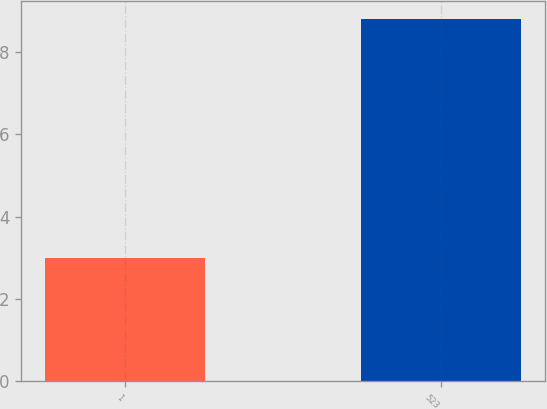Convert chart to OTSL. <chart><loc_0><loc_0><loc_500><loc_500><bar_chart><fcel>1<fcel>523<nl><fcel>3<fcel>8.8<nl></chart> 